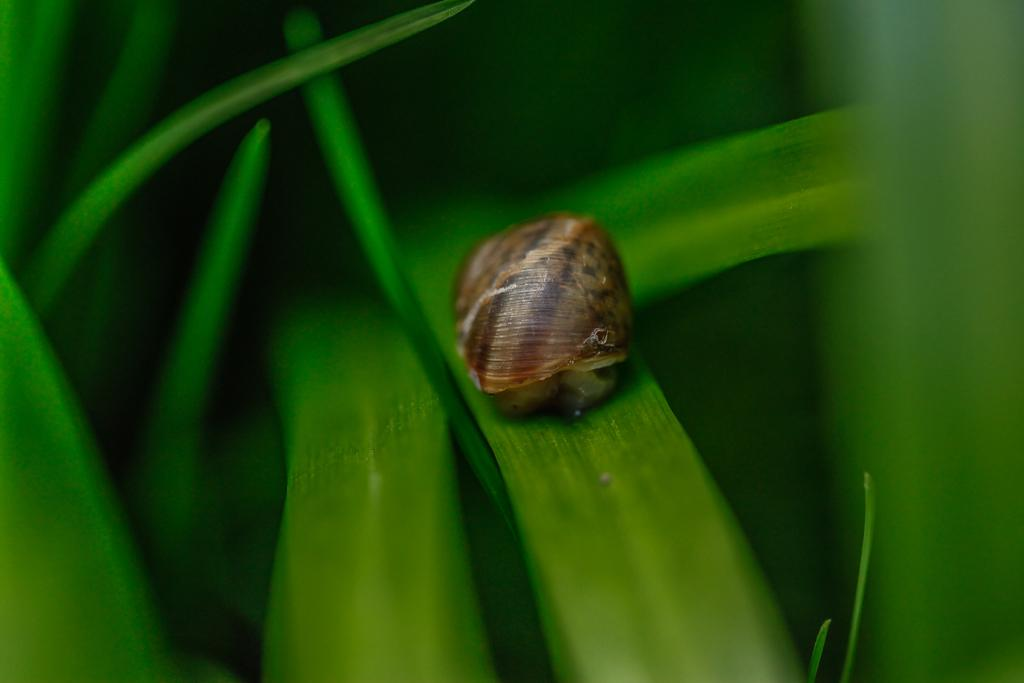What is the main subject in the foreground of the picture? There is a snail in the foreground of the picture. What is the snail resting on? The snail is on a leaf. What can be seen around the snail? There are leaves visible around the snail. What color is the yarn wrapped around the hydrant in the image? There is no hydrant or yarn present in the image; it features a snail on a leaf with surrounding leaves. 